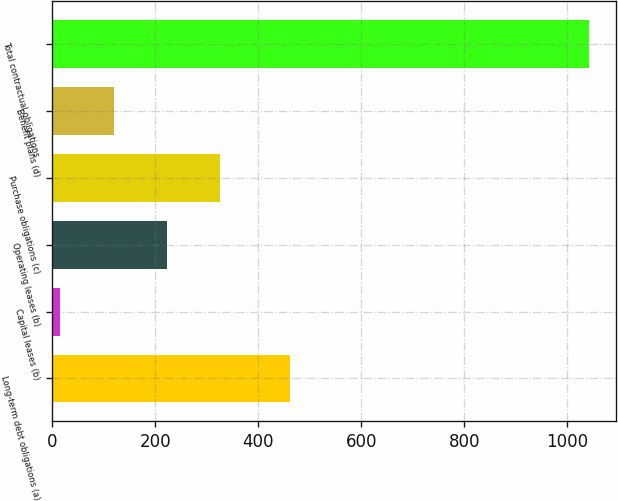Convert chart. <chart><loc_0><loc_0><loc_500><loc_500><bar_chart><fcel>Long-term debt obligations (a)<fcel>Capital leases (b)<fcel>Operating leases (b)<fcel>Purchase obligations (c)<fcel>Benefit plans (d)<fcel>Total contractual obligations<nl><fcel>462<fcel>16<fcel>222.6<fcel>325.2<fcel>120<fcel>1042<nl></chart> 